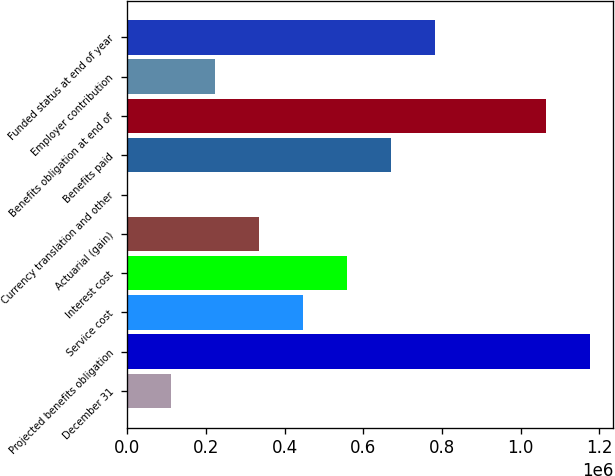Convert chart. <chart><loc_0><loc_0><loc_500><loc_500><bar_chart><fcel>December 31<fcel>Projected benefits obligation<fcel>Service cost<fcel>Interest cost<fcel>Actuarial (gain)<fcel>Currency translation and other<fcel>Benefits paid<fcel>Benefits obligation at end of<fcel>Employer contribution<fcel>Funded status at end of year<nl><fcel>111932<fcel>1.17693e+06<fcel>446693<fcel>558280<fcel>335106<fcel>345<fcel>669866<fcel>1.06534e+06<fcel>223519<fcel>781453<nl></chart> 